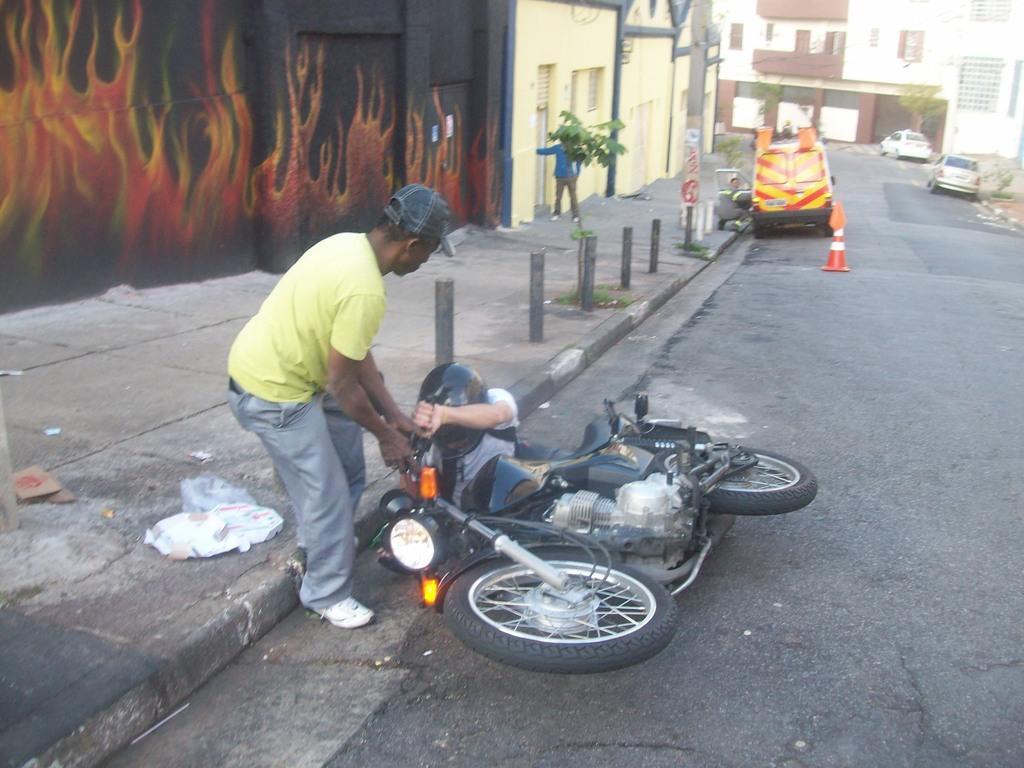In one or two sentences, can you explain what this image depicts? In this picture I can observe two members and a bike on the road in the middle of the picture. In the background there are buildings and some cars parked on the side of the road. 